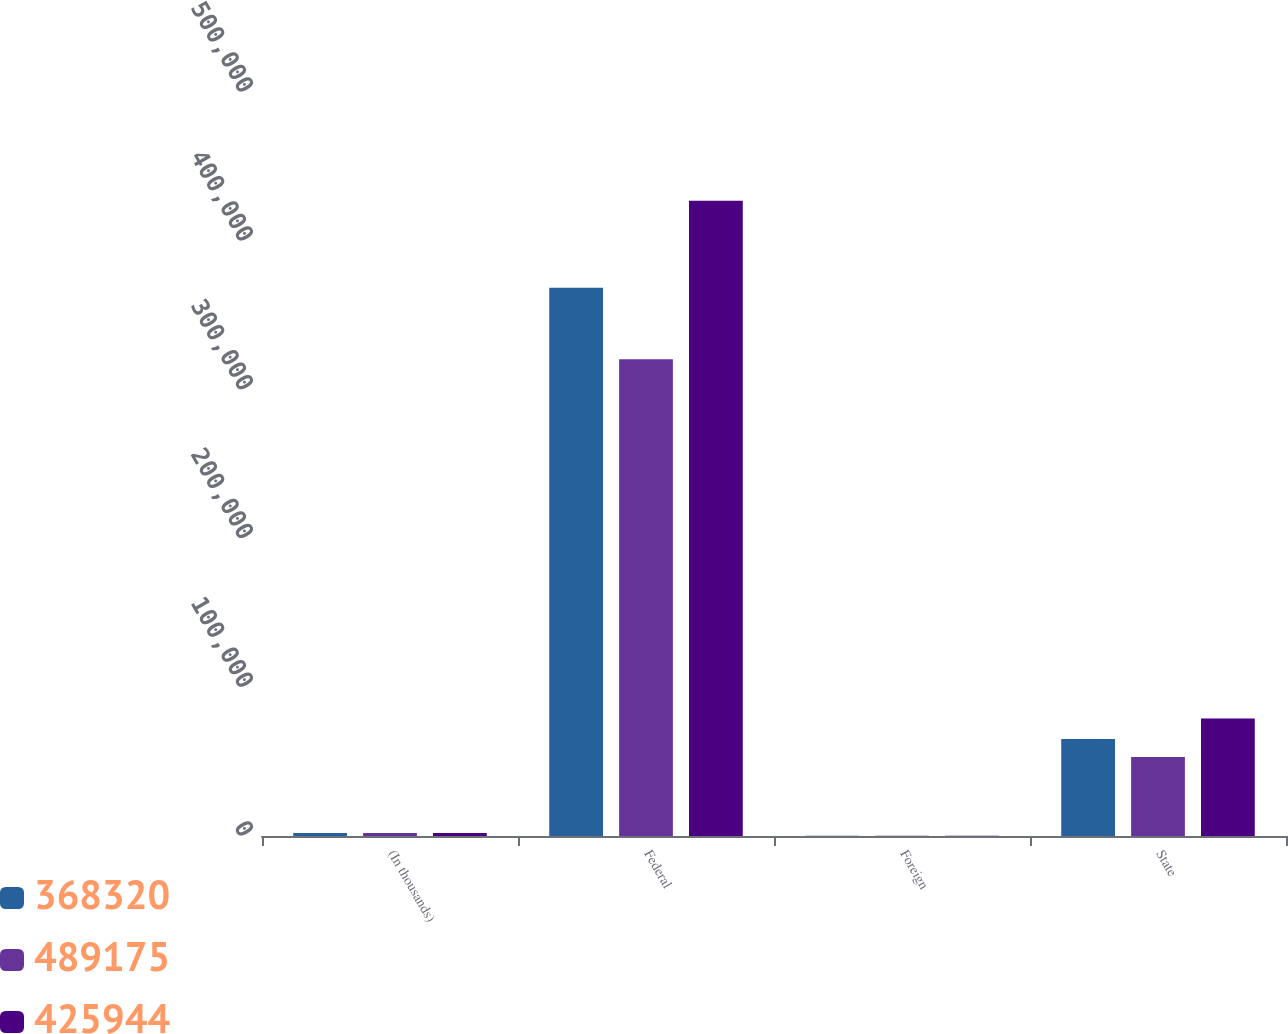<chart> <loc_0><loc_0><loc_500><loc_500><stacked_bar_chart><ecel><fcel>(In thousands)<fcel>Federal<fcel>Foreign<fcel>State<nl><fcel>368320<fcel>2019<fcel>368451<fcel>102<fcel>65215<nl><fcel>489175<fcel>2018<fcel>320361<fcel>159<fcel>53091<nl><fcel>425944<fcel>2017<fcel>426933<fcel>105<fcel>79011<nl></chart> 